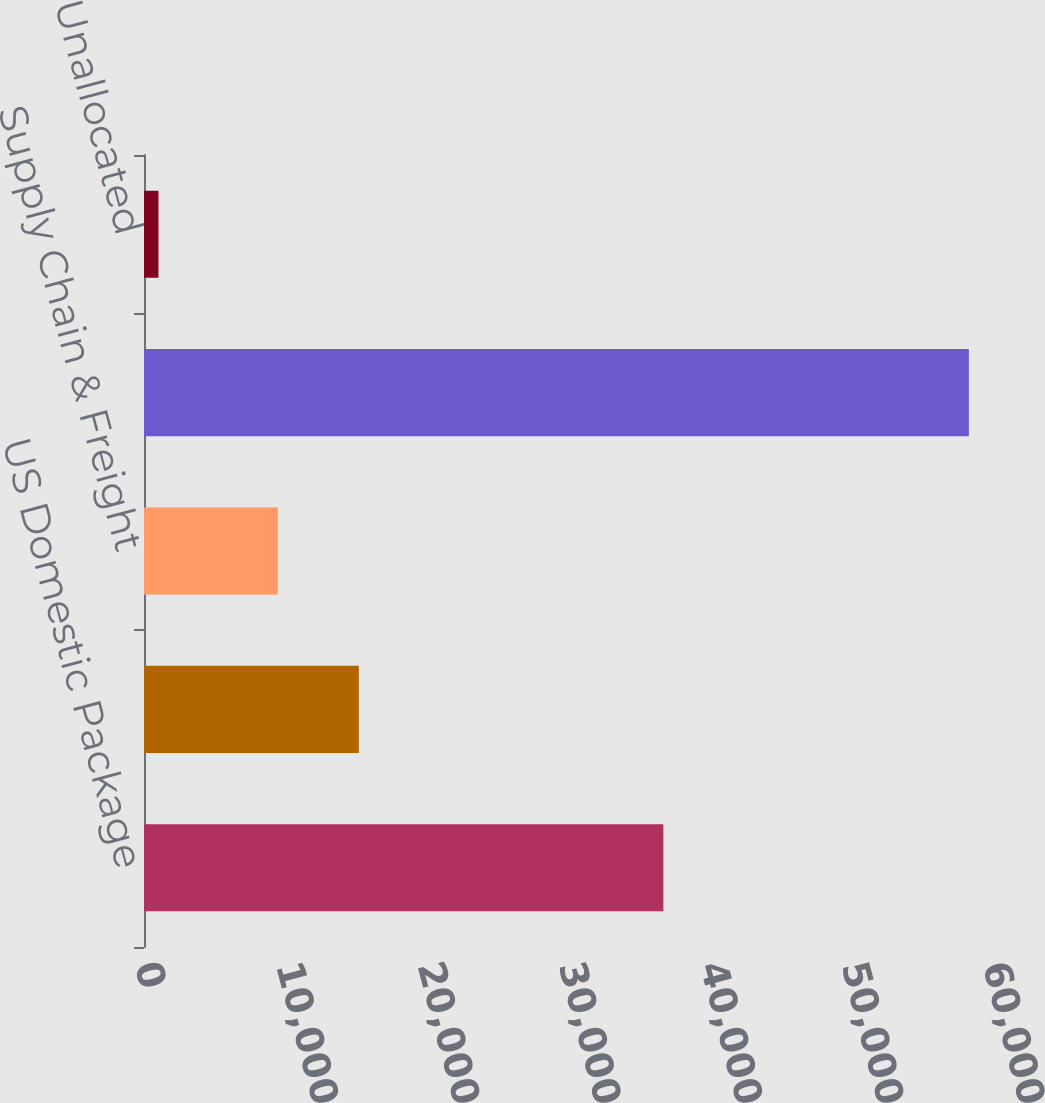Convert chart to OTSL. <chart><loc_0><loc_0><loc_500><loc_500><bar_chart><fcel>US Domestic Package<fcel>International Package<fcel>Supply Chain & Freight<fcel>Consolidated<fcel>Unallocated<nl><fcel>36747<fcel>15200.9<fcel>9467<fcel>58363<fcel>1024<nl></chart> 